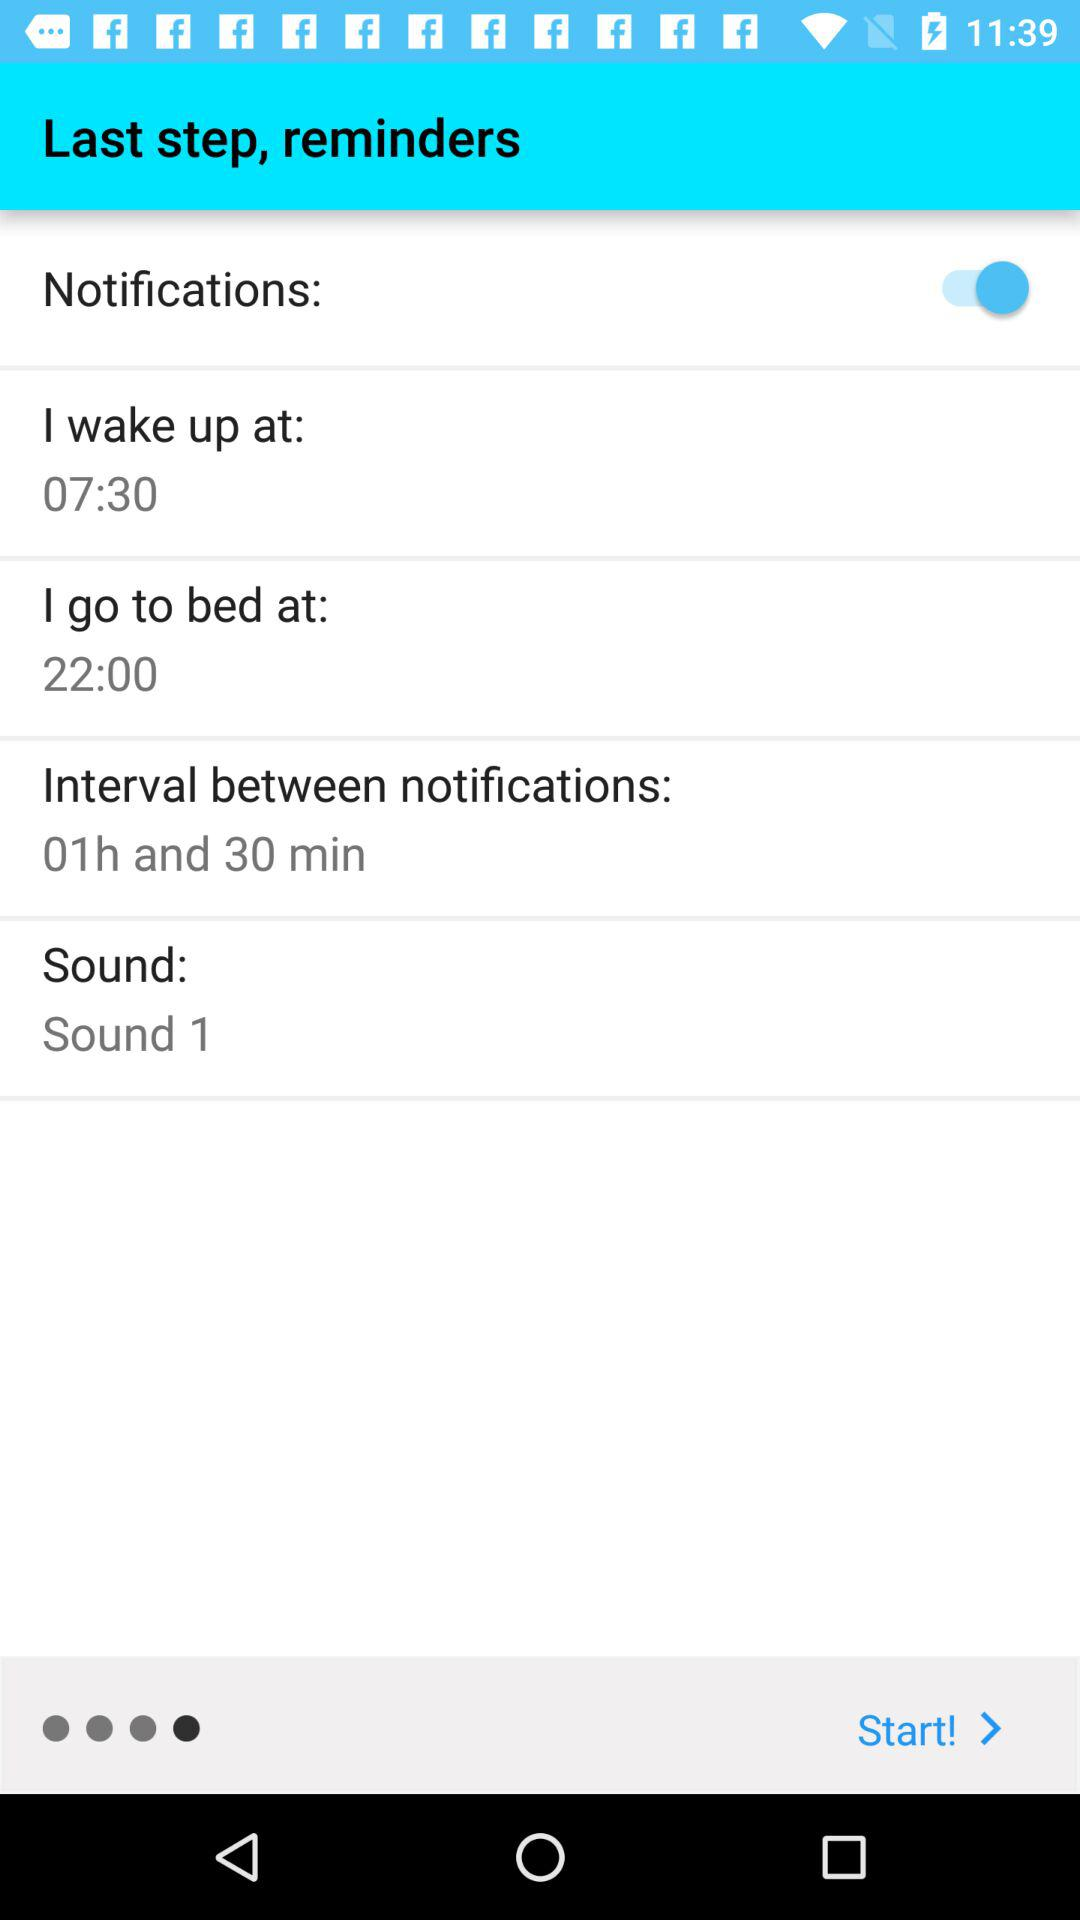What is the status of "Notifications"? The status is "on". 